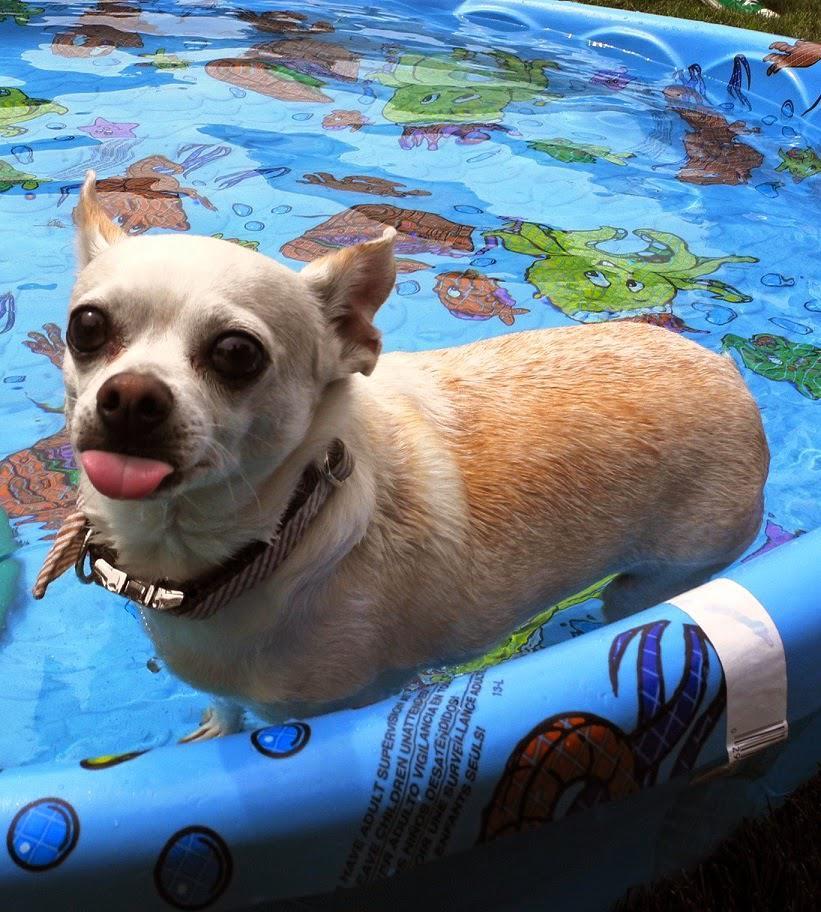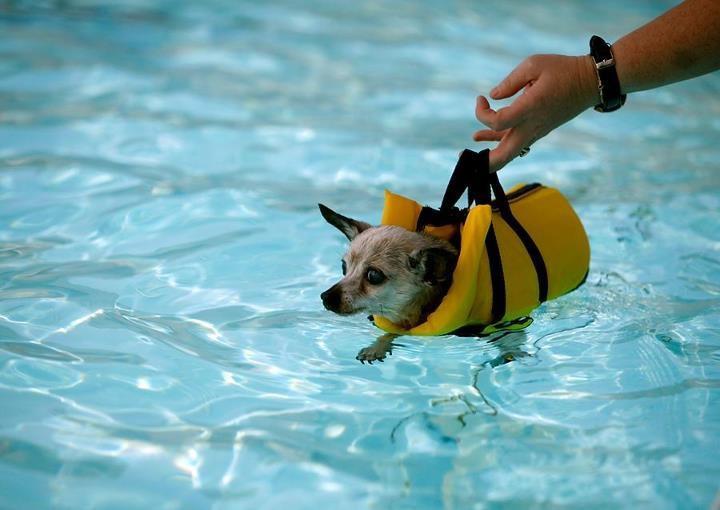The first image is the image on the left, the second image is the image on the right. For the images displayed, is the sentence "In one image, a small dog is standing in a kids' plastic pool, while the second image shows a similar dog in a large inground swimming pool, either in or near a floatation device." factually correct? Answer yes or no. Yes. The first image is the image on the left, the second image is the image on the right. Given the left and right images, does the statement "A single dog is standing up inside a kiddie pool, in one image." hold true? Answer yes or no. Yes. 